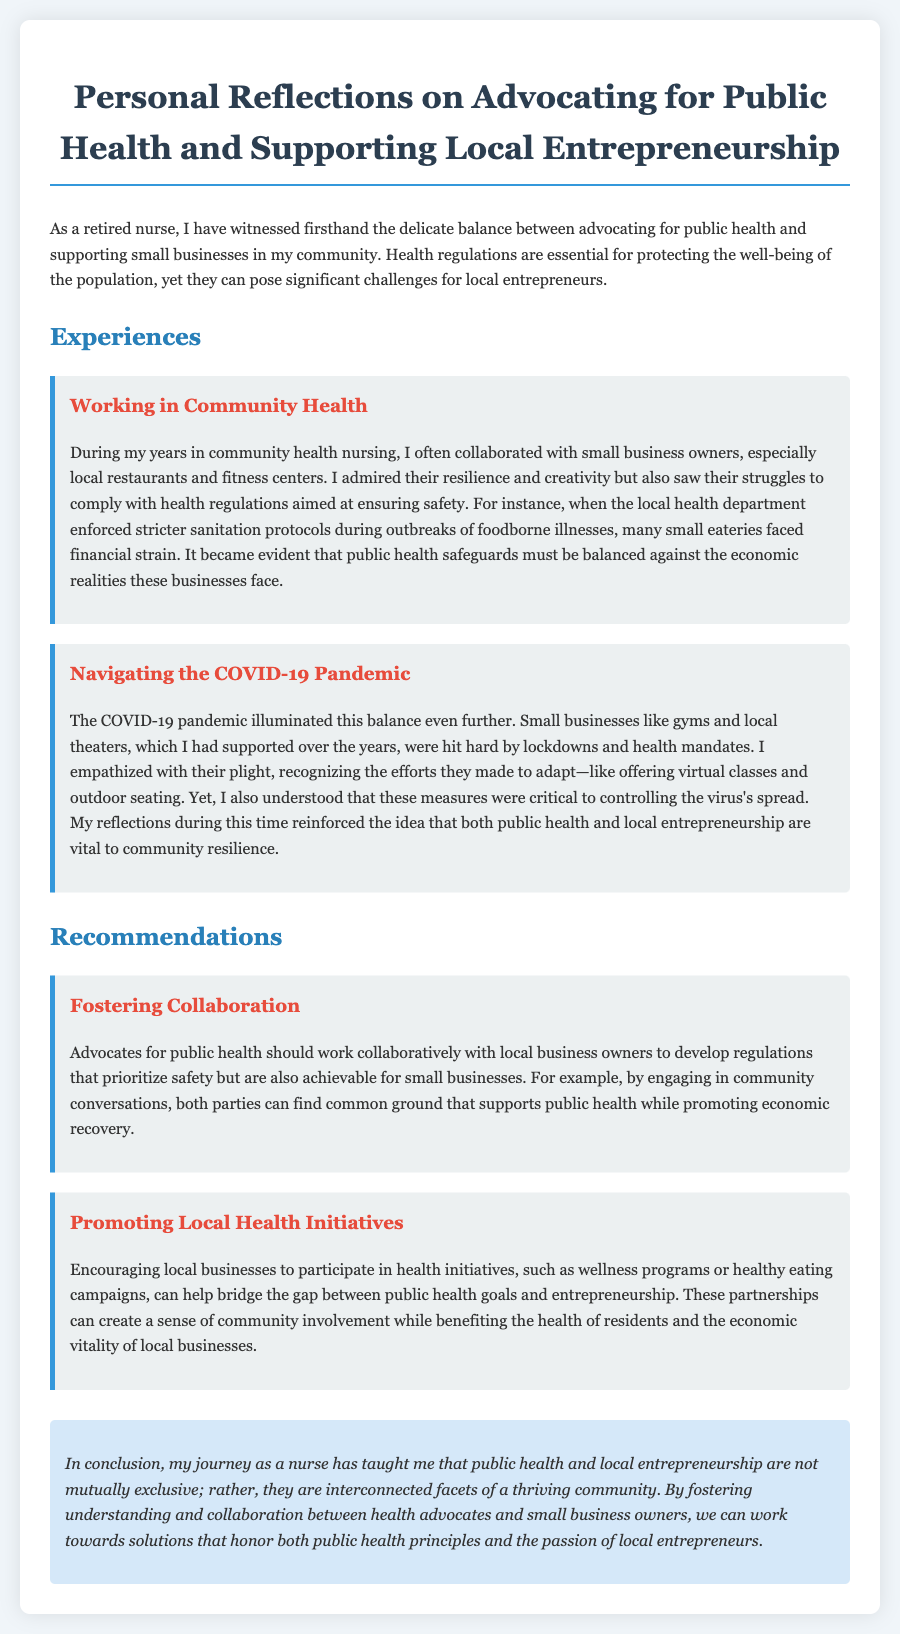What is the title of the document? The title can be found at the top of the document and summarizes its content regarding public health and entrepreneurship.
Answer: Personal Reflections on Advocating for Public Health and Supporting Local Entrepreneurship Who collaborated with small business owners during community health nursing? The document states that the author, as a retired nurse, collaborated with small business owners.
Answer: The author What did local business owners face during outbreaks of foodborne illnesses? The document mentions the financial strain that small eateries experienced due to health regulations during outbreaks.
Answer: Financial strain What pandemic is discussed in relation to local businesses' struggles? The document explicitly mentions the COVID-19 pandemic as a significant challenge for local entrepreneurs.
Answer: COVID-19 How did small businesses adapt during the COVID-19 pandemic? The document describes that small businesses implemented measures like offering virtual classes and outdoor seating to cope with health mandates.
Answer: Virtual classes and outdoor seating What is one recommendation for supporting both public health and local entrepreneurship? The document suggests fostering collaboration between health advocates and local business owners to develop regulations that are achievable for small businesses.
Answer: Fostering collaboration What two aspects are emphasized as vital to community resilience? The document highlights that both public health and local entrepreneurship are essential for a thriving community.
Answer: Public health and local entrepreneurship What is the color of the heading for the Experiences section? The specific heading color for the Experiences section is defined in the document's style and is described.
Answer: Blue 